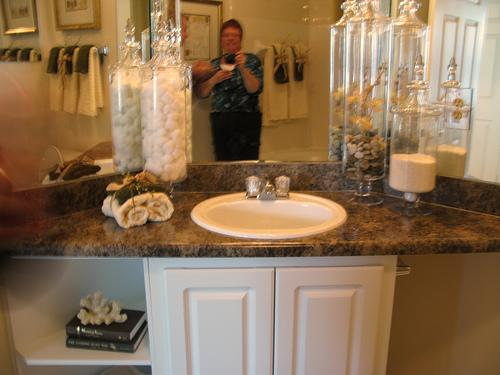What material are the white rounds in the jar made of? cotton 